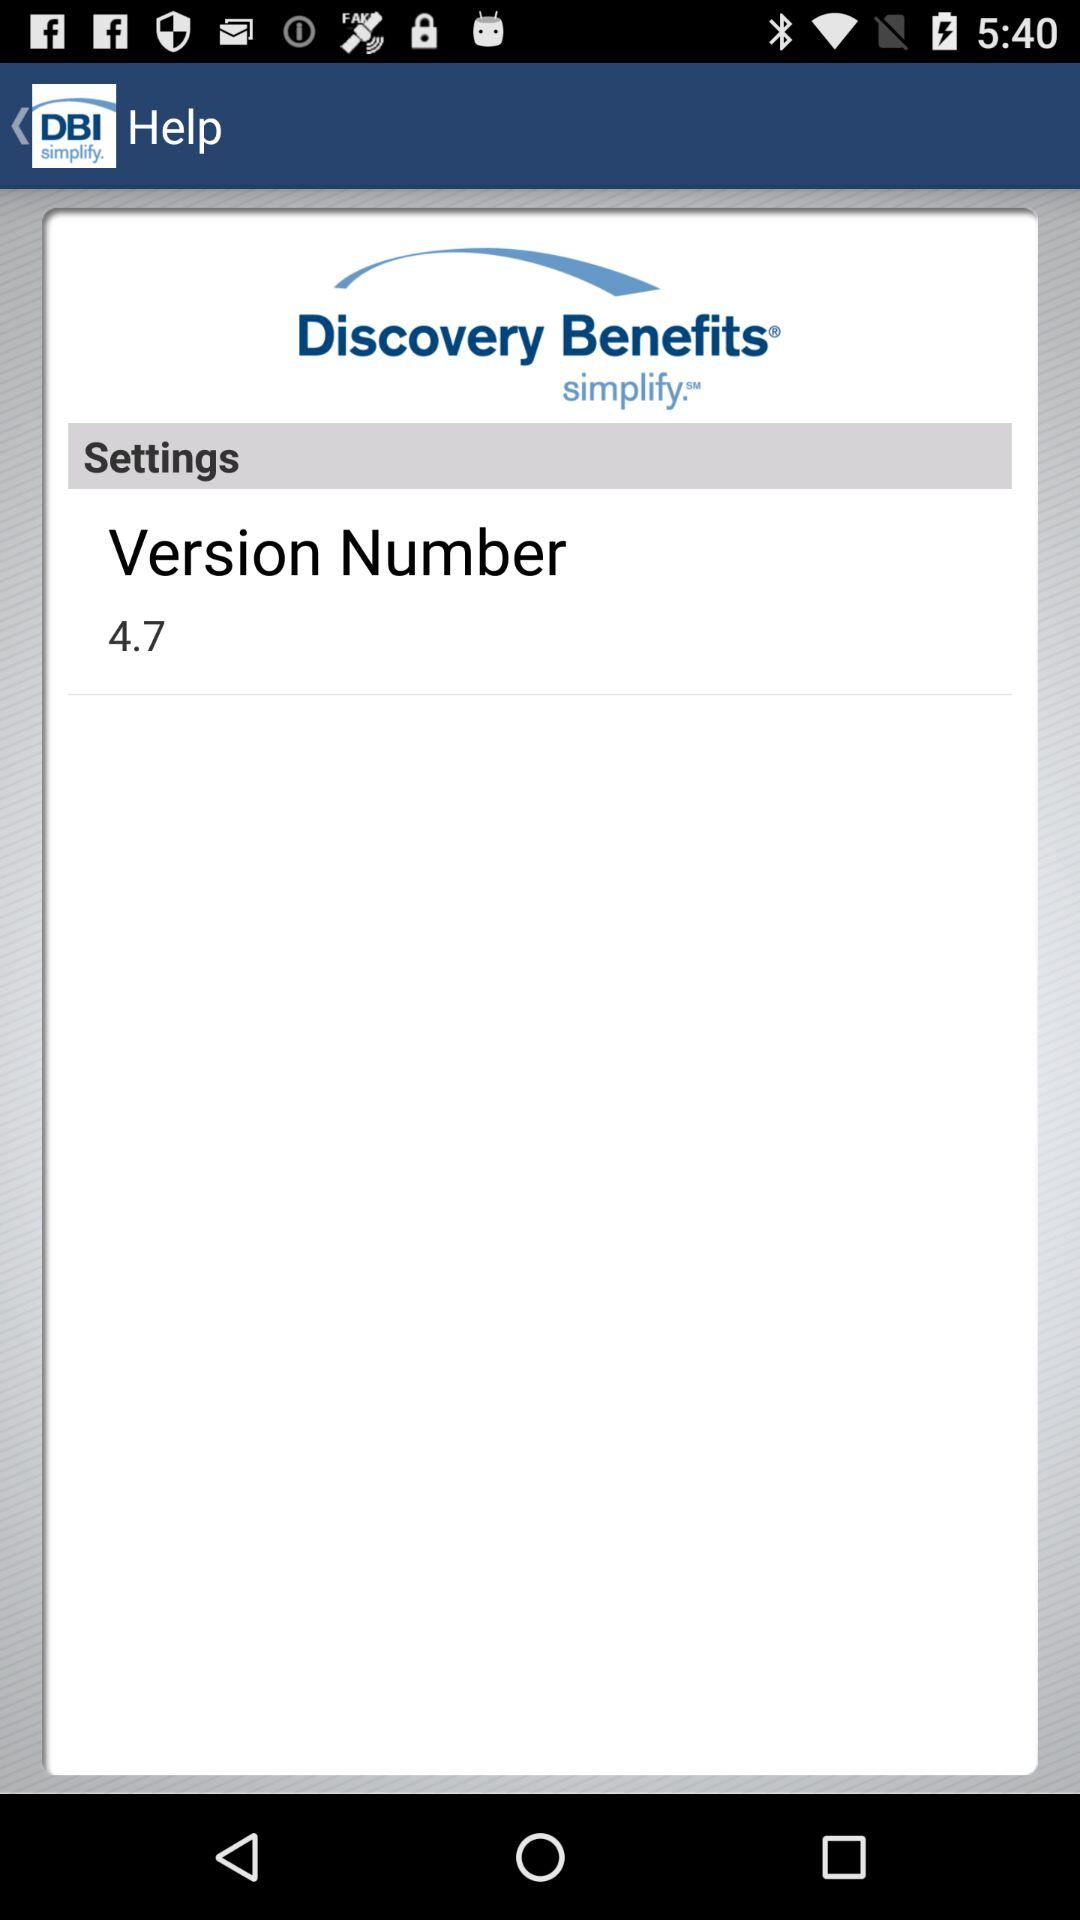What is the version number of the application? The version number is 4.7. 